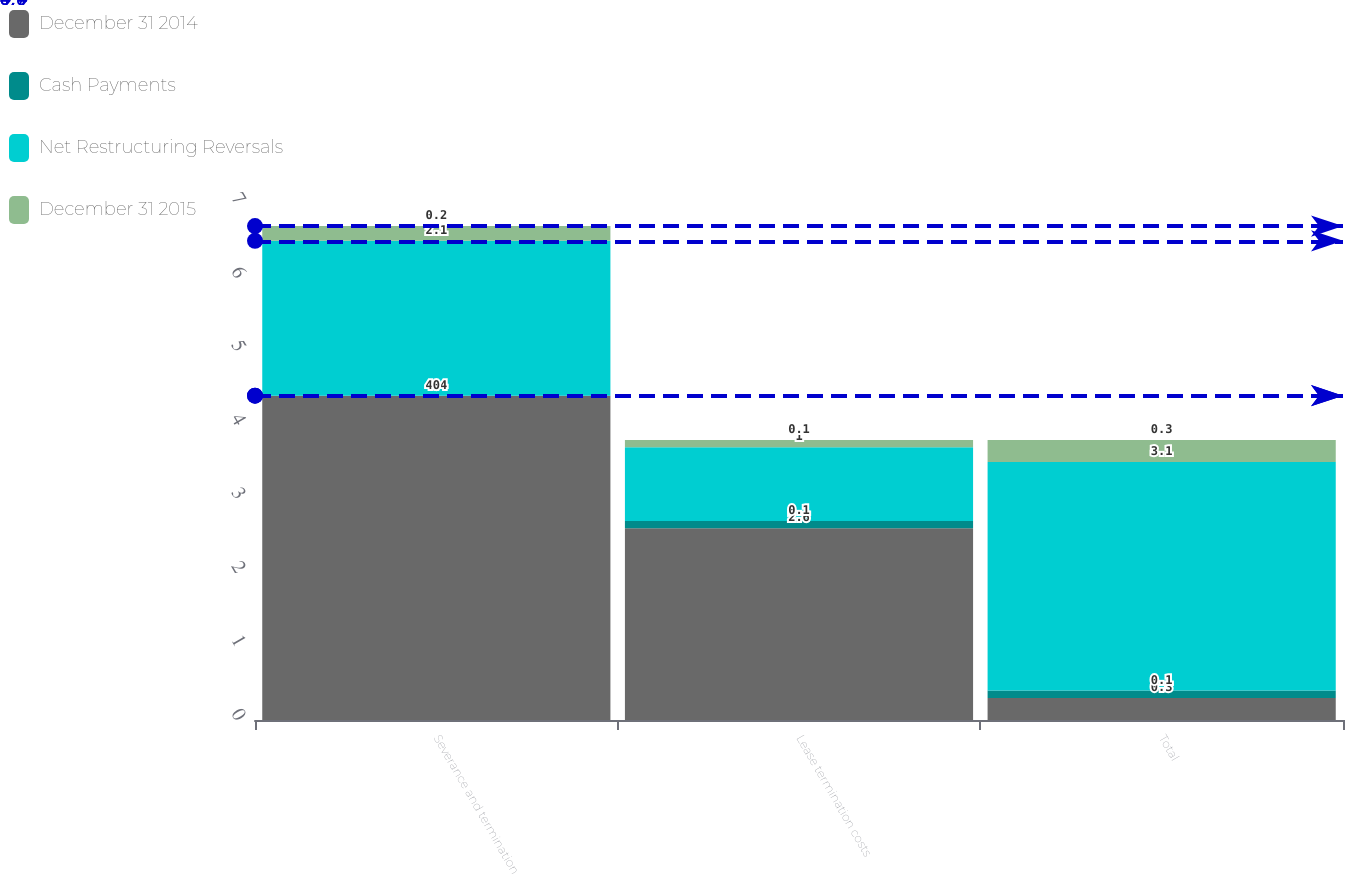<chart> <loc_0><loc_0><loc_500><loc_500><stacked_bar_chart><ecel><fcel>Severance and termination<fcel>Lease termination costs<fcel>Total<nl><fcel>December 31 2014<fcel>4.4<fcel>2.6<fcel>0.3<nl><fcel>Cash Payments<fcel>0<fcel>0.1<fcel>0.1<nl><fcel>Net Restructuring Reversals<fcel>2.1<fcel>1<fcel>3.1<nl><fcel>December 31 2015<fcel>0.2<fcel>0.1<fcel>0.3<nl></chart> 